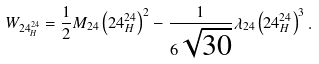<formula> <loc_0><loc_0><loc_500><loc_500>W _ { 2 4 _ { H } ^ { 2 4 } } = \frac { 1 } { 2 } M _ { 2 4 } \left ( 2 4 _ { H } ^ { 2 4 } \right ) ^ { 2 } - \frac { 1 } { 6 \sqrt { 3 0 } } \lambda _ { 2 4 } \left ( 2 4 _ { H } ^ { 2 4 } \right ) ^ { 3 } .</formula> 